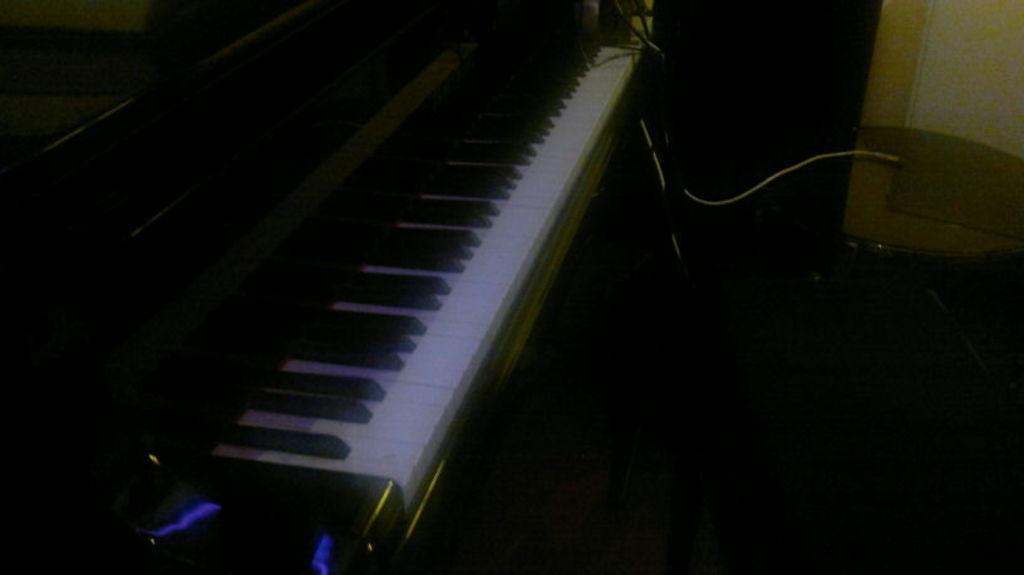Describe this image in one or two sentences. In this image we can see a piano, cable, table, and a wall. 